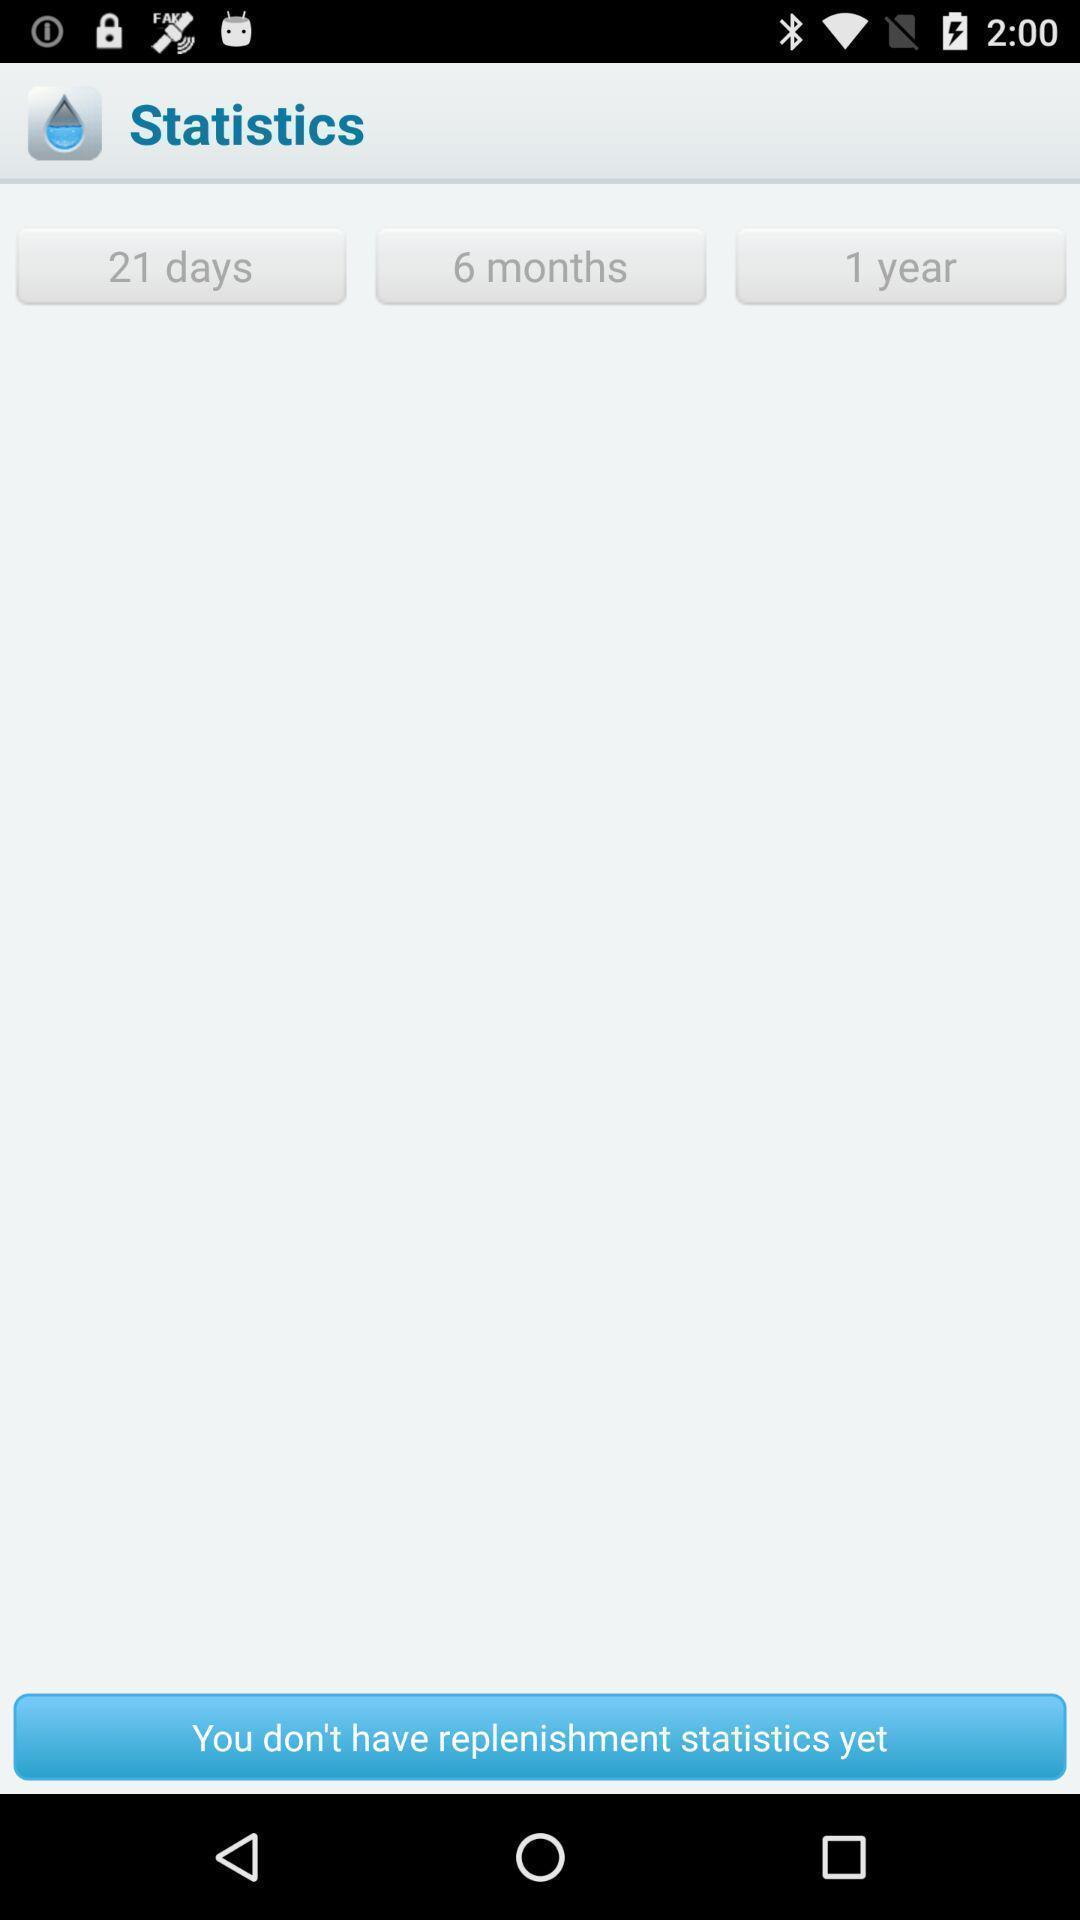Provide a detailed account of this screenshot. Page showing the statistics. 